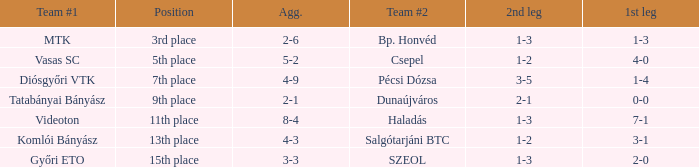What is the 1st leg with a 4-3 agg.? 3-1. 